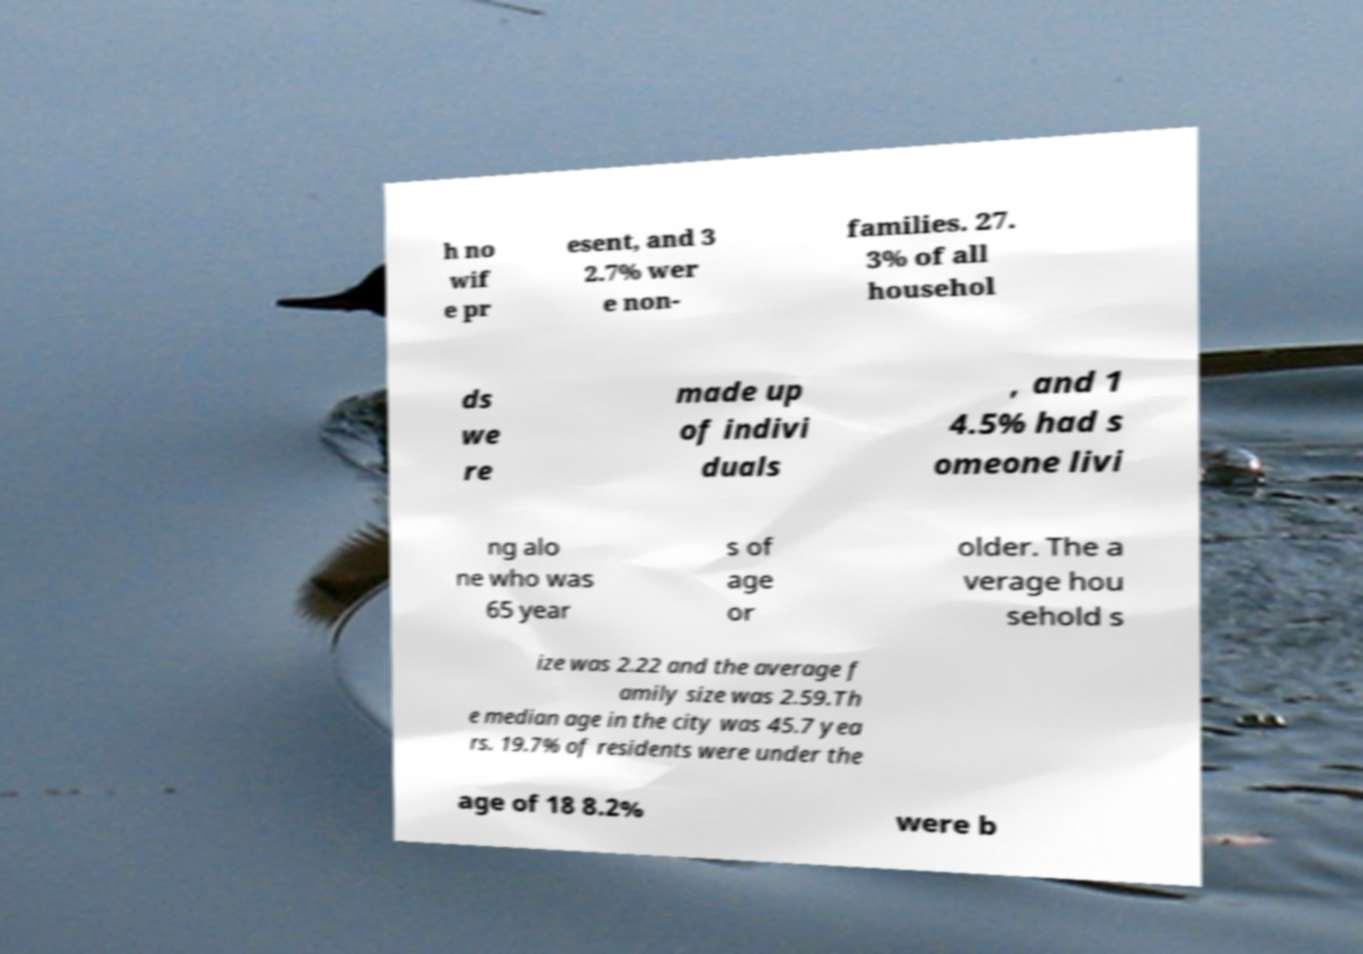I need the written content from this picture converted into text. Can you do that? h no wif e pr esent, and 3 2.7% wer e non- families. 27. 3% of all househol ds we re made up of indivi duals , and 1 4.5% had s omeone livi ng alo ne who was 65 year s of age or older. The a verage hou sehold s ize was 2.22 and the average f amily size was 2.59.Th e median age in the city was 45.7 yea rs. 19.7% of residents were under the age of 18 8.2% were b 